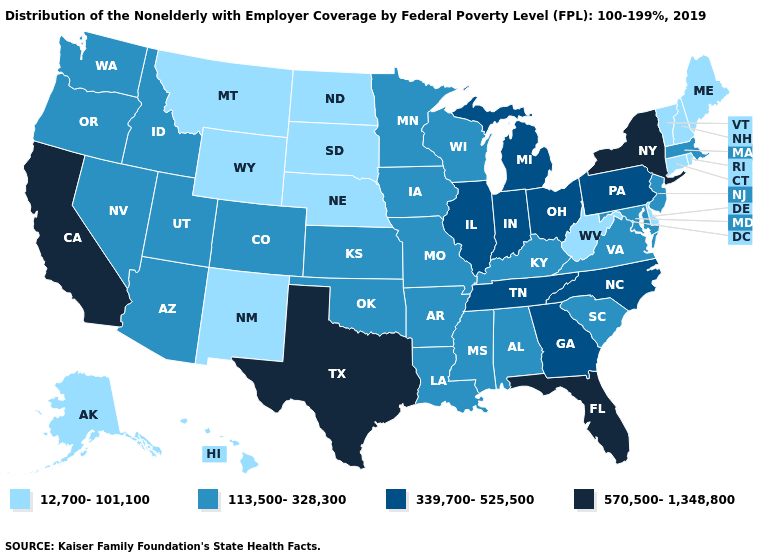Does the map have missing data?
Give a very brief answer. No. Name the states that have a value in the range 339,700-525,500?
Quick response, please. Georgia, Illinois, Indiana, Michigan, North Carolina, Ohio, Pennsylvania, Tennessee. What is the highest value in states that border Oklahoma?
Answer briefly. 570,500-1,348,800. Does the map have missing data?
Concise answer only. No. What is the lowest value in the Northeast?
Answer briefly. 12,700-101,100. Does Georgia have a lower value than Florida?
Keep it brief. Yes. What is the value of Nebraska?
Answer briefly. 12,700-101,100. Does Louisiana have the lowest value in the USA?
Be succinct. No. What is the highest value in states that border Arizona?
Give a very brief answer. 570,500-1,348,800. Name the states that have a value in the range 113,500-328,300?
Be succinct. Alabama, Arizona, Arkansas, Colorado, Idaho, Iowa, Kansas, Kentucky, Louisiana, Maryland, Massachusetts, Minnesota, Mississippi, Missouri, Nevada, New Jersey, Oklahoma, Oregon, South Carolina, Utah, Virginia, Washington, Wisconsin. What is the value of Tennessee?
Answer briefly. 339,700-525,500. Does New York have the highest value in the Northeast?
Quick response, please. Yes. Name the states that have a value in the range 339,700-525,500?
Concise answer only. Georgia, Illinois, Indiana, Michigan, North Carolina, Ohio, Pennsylvania, Tennessee. Does Florida have the highest value in the USA?
Concise answer only. Yes. Does Florida have the same value as New York?
Write a very short answer. Yes. 